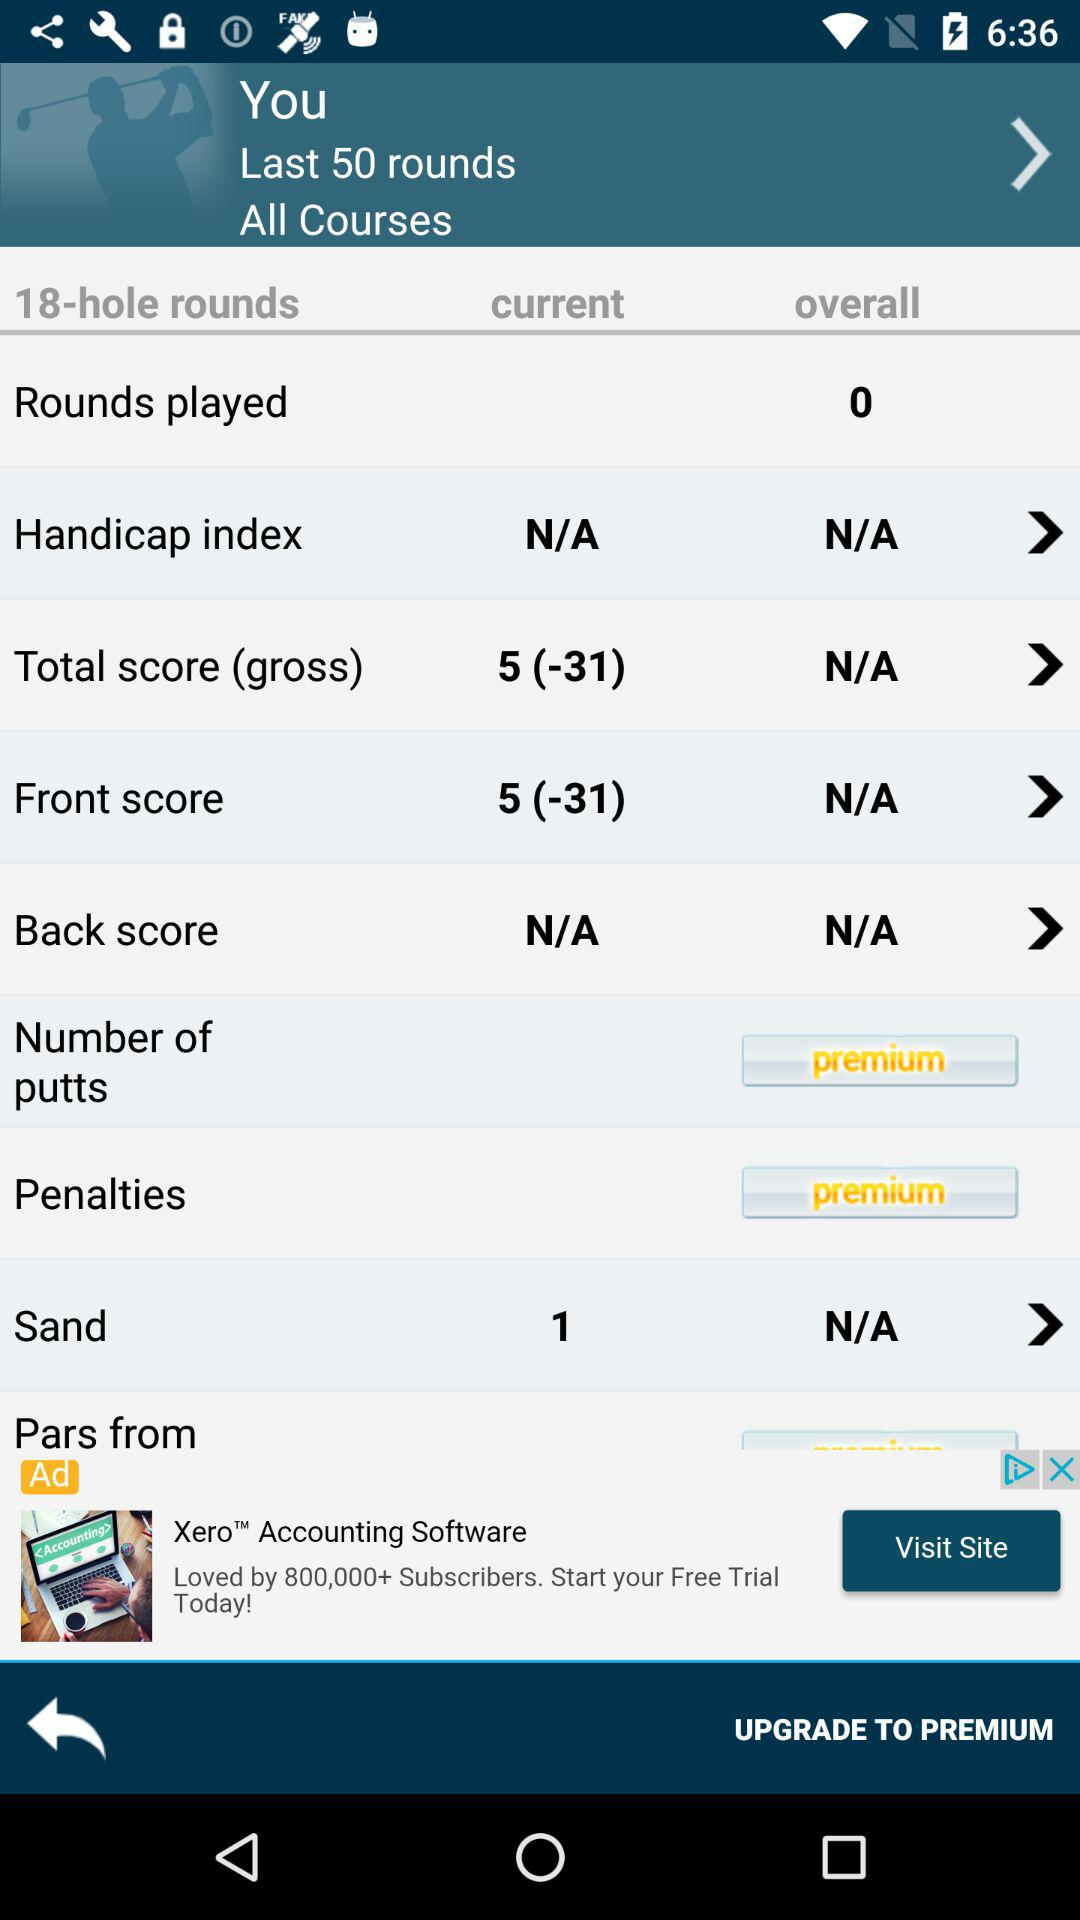How many rounds were played overall? There were 0 rounds played. 